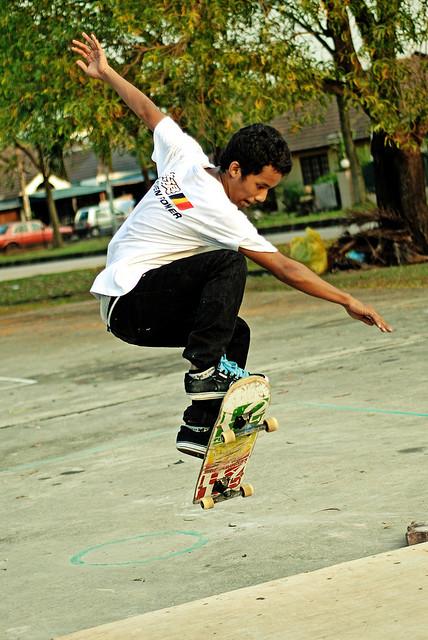Is the skateboarder wearing jeans?
Quick response, please. Yes. Should the boy where a helmet?
Be succinct. Yes. How many wheels are on this skateboard?
Short answer required. 4. What color are his shoes?
Short answer required. Black. Does the boy need balance?
Answer briefly. Yes. 